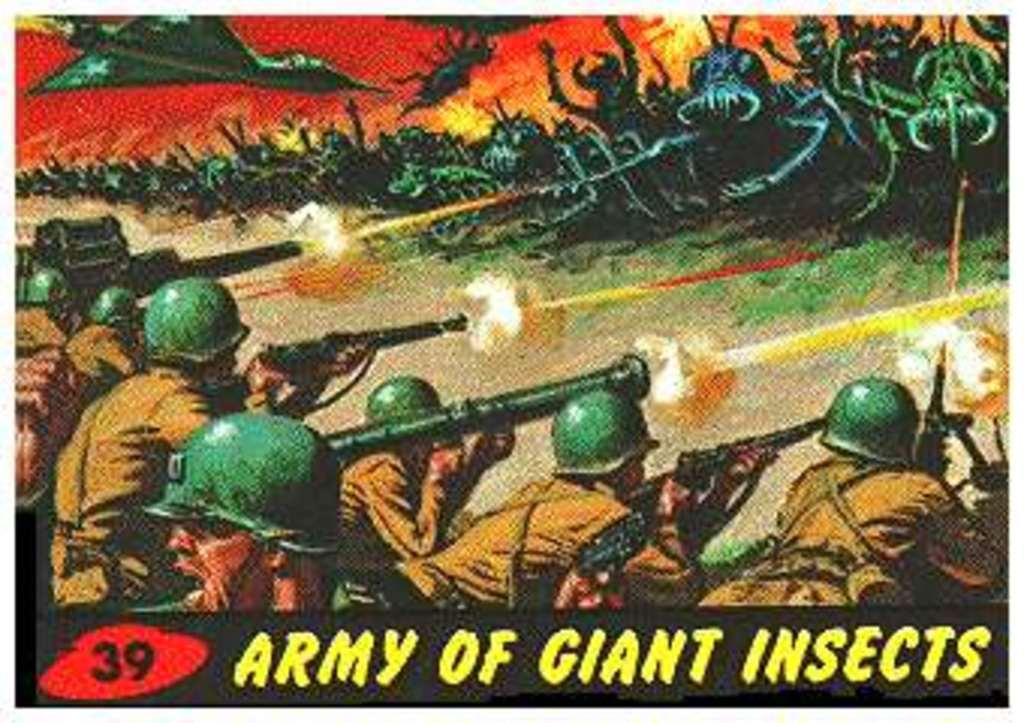What is the main subject of the poster in the image? The poster contains people holding guns. What else can be seen on the poster besides the people holding guns? There is text on the poster. What type of collar is visible on the rock in the image? There is no rock or collar present in the image. 